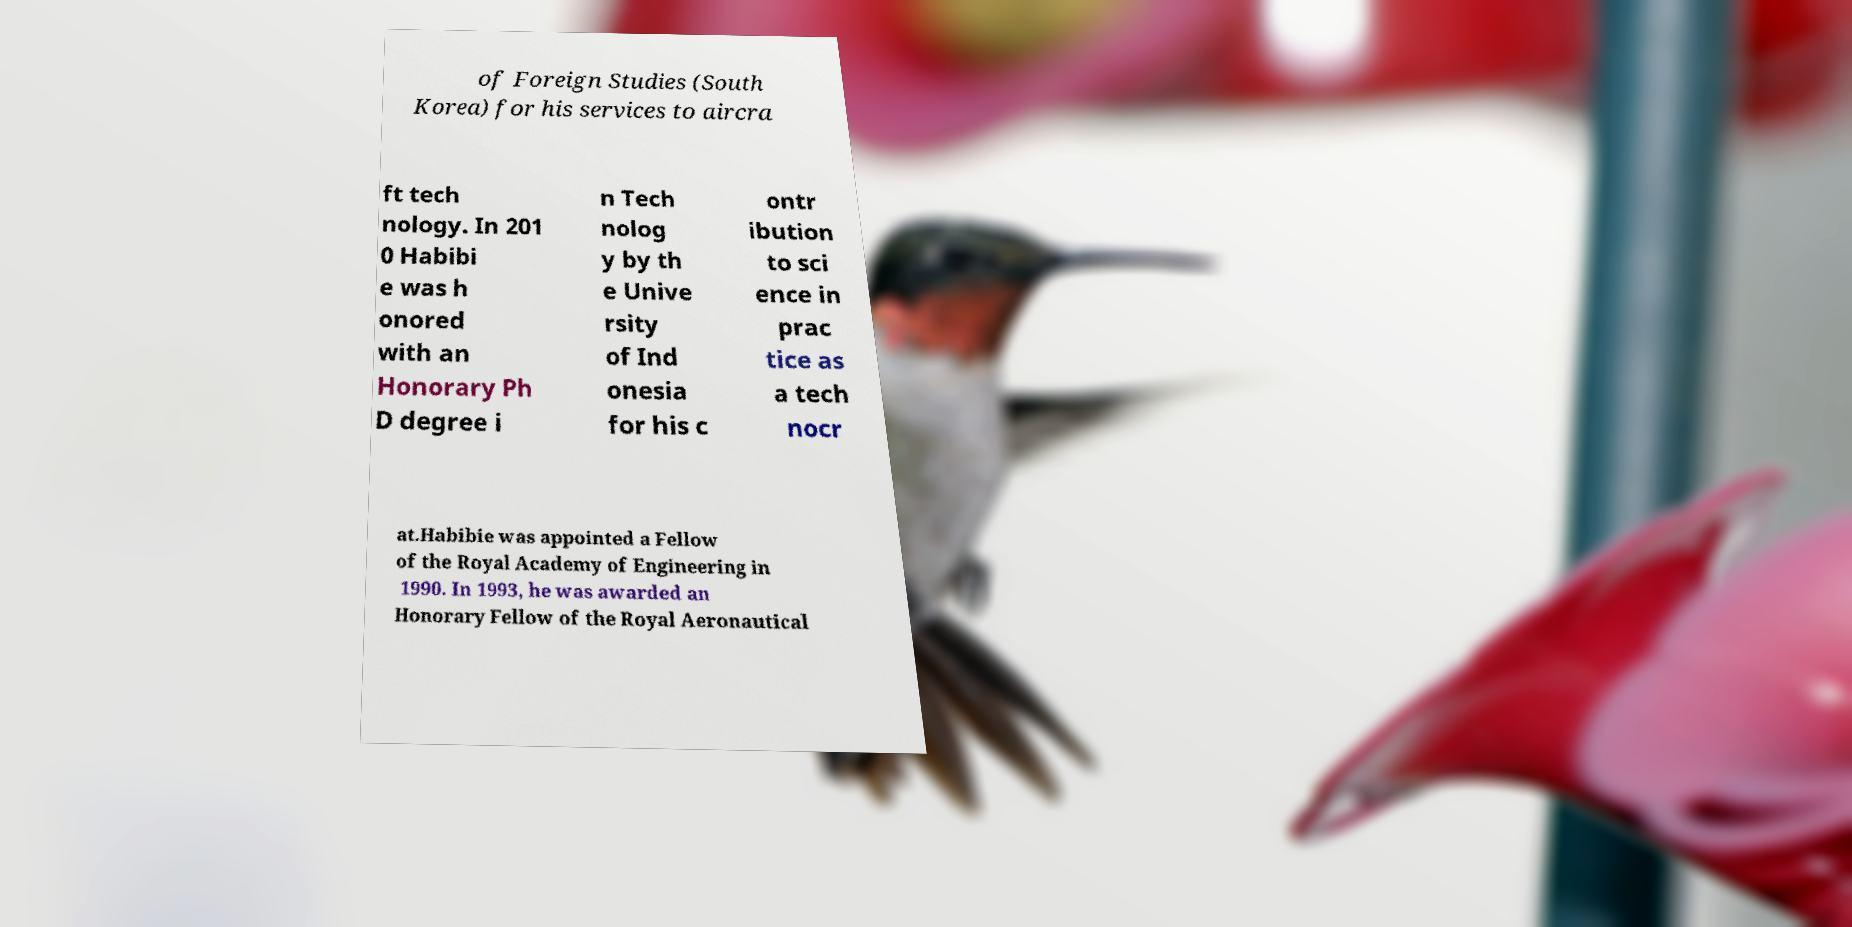Please identify and transcribe the text found in this image. of Foreign Studies (South Korea) for his services to aircra ft tech nology. In 201 0 Habibi e was h onored with an Honorary Ph D degree i n Tech nolog y by th e Unive rsity of Ind onesia for his c ontr ibution to sci ence in prac tice as a tech nocr at.Habibie was appointed a Fellow of the Royal Academy of Engineering in 1990. In 1993, he was awarded an Honorary Fellow of the Royal Aeronautical 